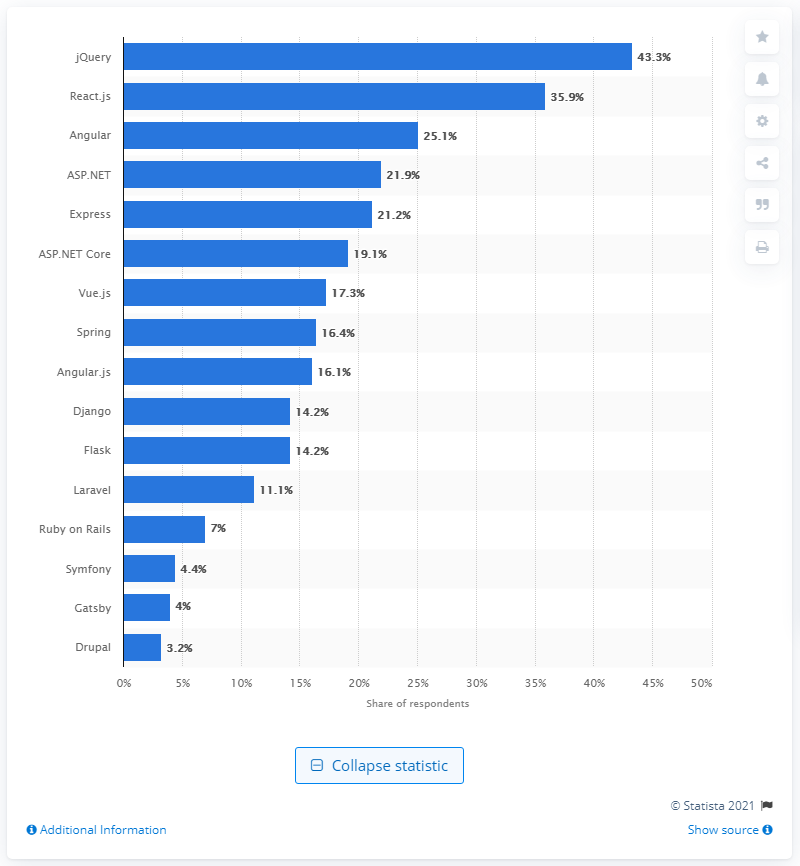What information does the visual representation provide about the trends in technology preferences? The bar chart visualizes the distribution of technology preference among respondents, suggesting that jQuery, React.js, and Angular are the top three preferred technologies. It also indicates a trend toward newer JavaScript frameworks and libraries like React.js and Angular over traditional ones like jQuery. 